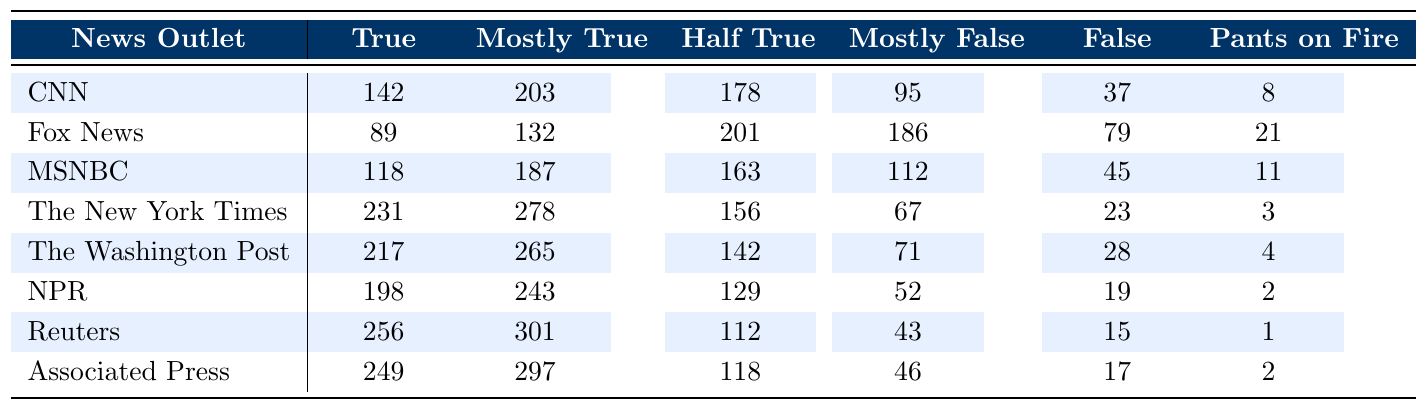What is the total number of "True" fact-checked articles by CNN? CNN has 142 articles categorized as "True" according to the table.
Answer: 142 Which news outlet has the highest number of "False" claims? By checking the under the "False" column, Fox News has 79 articles categorized as "False", which is the highest among the outlets listed.
Answer: 79 How many "Pants on Fire" claims did Reuters and NPR have combined? Reuters has 1 claim while NPR has 2, adding these together gives 1 + 2 = 3.
Answer: 3 What is the average number of "Mostly True" claims across all news outlets? The total number of "Mostly True" claims is (203 + 132 + 187 + 278 + 265 + 243 + 301 + 297) = 1888, and there are 8 outlets, so the average is 1888 / 8 = 236.
Answer: 236 Which outlet has the lowest number of "True" articles? Looking at the "True" column, Fox News has the lowest count with 89 articles.
Answer: Fox News Is it true that The New York Times has more "False" claims than MSNBC? The New York Times has 23 "False" claims while MSNBC has 45, showing that MSNBC has more. Thus, it is false that The New York Times has more "False" claims than MSNBC.
Answer: No What is the difference in the number of "Half True" claims between Associated Press and CNN? Associated Press has 118 "Half True" claims while CNN has 178. The difference is 178 - 118 = 60.
Answer: 60 Which news outlet has the highest "Pants on Fire" rating? By reviewing the "Pants on Fire" column, Fox News has the highest number at 21, which is greater than the other outlets.
Answer: Fox News How many total fact-check articles did The Washington Post review? To find the total, sum all the categories for The Washington Post: 217 + 265 + 142 + 71 + 28 + 4 = 727.
Answer: 727 If we combine the "Mostly True" articles from NPR and The New York Times, what is the total? NPR has 243 "Mostly True" articles and The New York Times has 278; together they total 243 + 278 = 521.
Answer: 521 